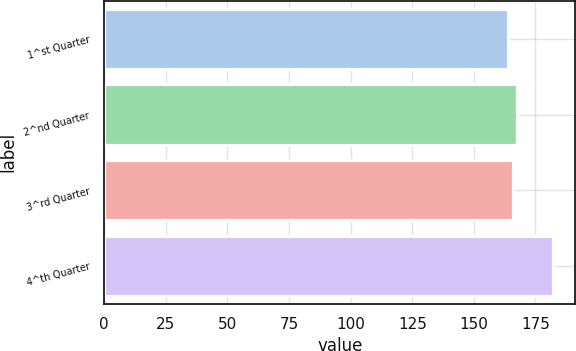Convert chart to OTSL. <chart><loc_0><loc_0><loc_500><loc_500><bar_chart><fcel>1^st Quarter<fcel>2^nd Quarter<fcel>3^rd Quarter<fcel>4^th Quarter<nl><fcel>164<fcel>167.62<fcel>165.81<fcel>182.11<nl></chart> 